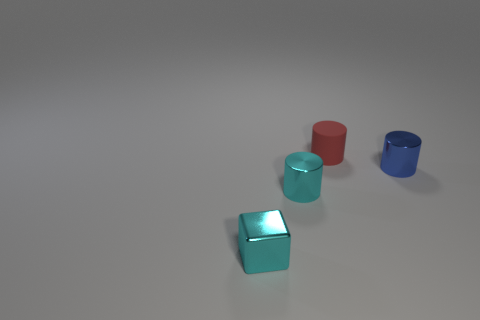Add 1 cyan metallic objects. How many objects exist? 5 Subtract all cylinders. How many objects are left? 1 Add 1 cylinders. How many cylinders exist? 4 Subtract 0 cyan spheres. How many objects are left? 4 Subtract all cylinders. Subtract all large brown metallic things. How many objects are left? 1 Add 4 small metallic blocks. How many small metallic blocks are left? 5 